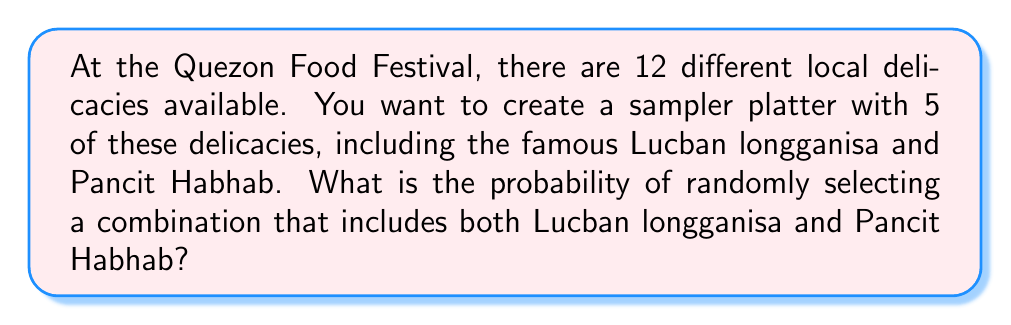Can you solve this math problem? Let's approach this step-by-step:

1) First, we need to understand what we're given:
   - There are 12 total delicacies
   - We're selecting 5 delicacies
   - 2 specific delicacies (Lucban longganisa and Pancit Habhab) must be included

2) Since we must include Lucban longganisa and Pancit Habhab, we only need to choose 3 more delicacies from the remaining 10.

3) The number of ways to choose 3 delicacies from 10 is given by the combination formula:

   $$\binom{10}{3} = \frac{10!}{3!(10-3)!} = \frac{10!}{3!7!} = 120$$

4) This represents the number of favorable outcomes.

5) Now, we need to calculate the total number of possible ways to choose 5 delicacies from 12:

   $$\binom{12}{5} = \frac{12!}{5!(12-5)!} = \frac{12!}{5!7!} = 792$$

6) The probability is then the number of favorable outcomes divided by the total number of possible outcomes:

   $$P(\text{Lucban longganisa and Pancit Habhab}) = \frac{120}{792} = \frac{15}{99} \approx 0.1515$$
Answer: $\frac{15}{99}$ 